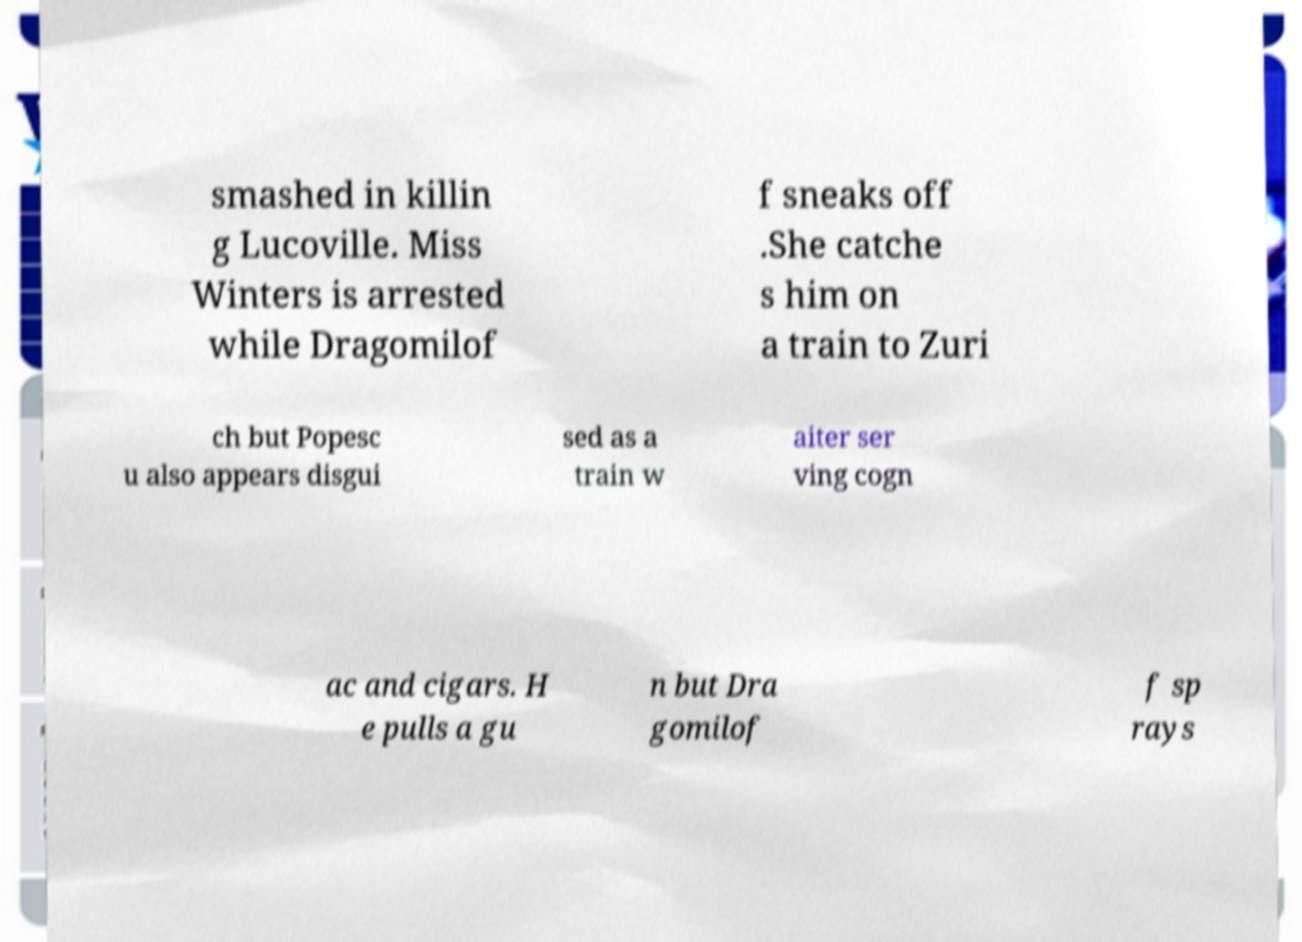Could you extract and type out the text from this image? smashed in killin g Lucoville. Miss Winters is arrested while Dragomilof f sneaks off .She catche s him on a train to Zuri ch but Popesc u also appears disgui sed as a train w aiter ser ving cogn ac and cigars. H e pulls a gu n but Dra gomilof f sp rays 